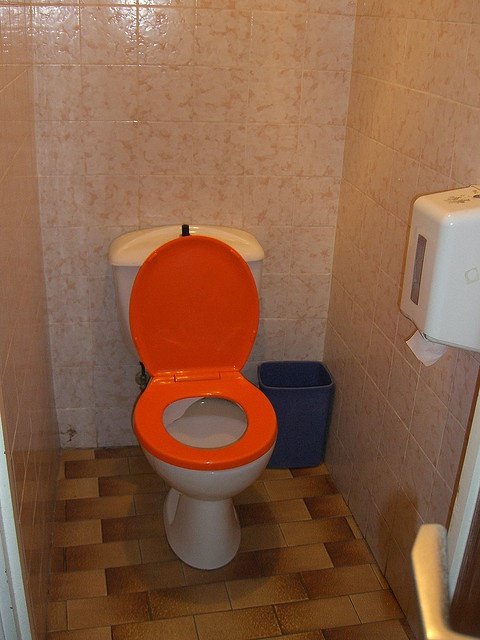Describe the objects in this image and their specific colors. I can see a toilet in tan, brown, gray, and red tones in this image. 